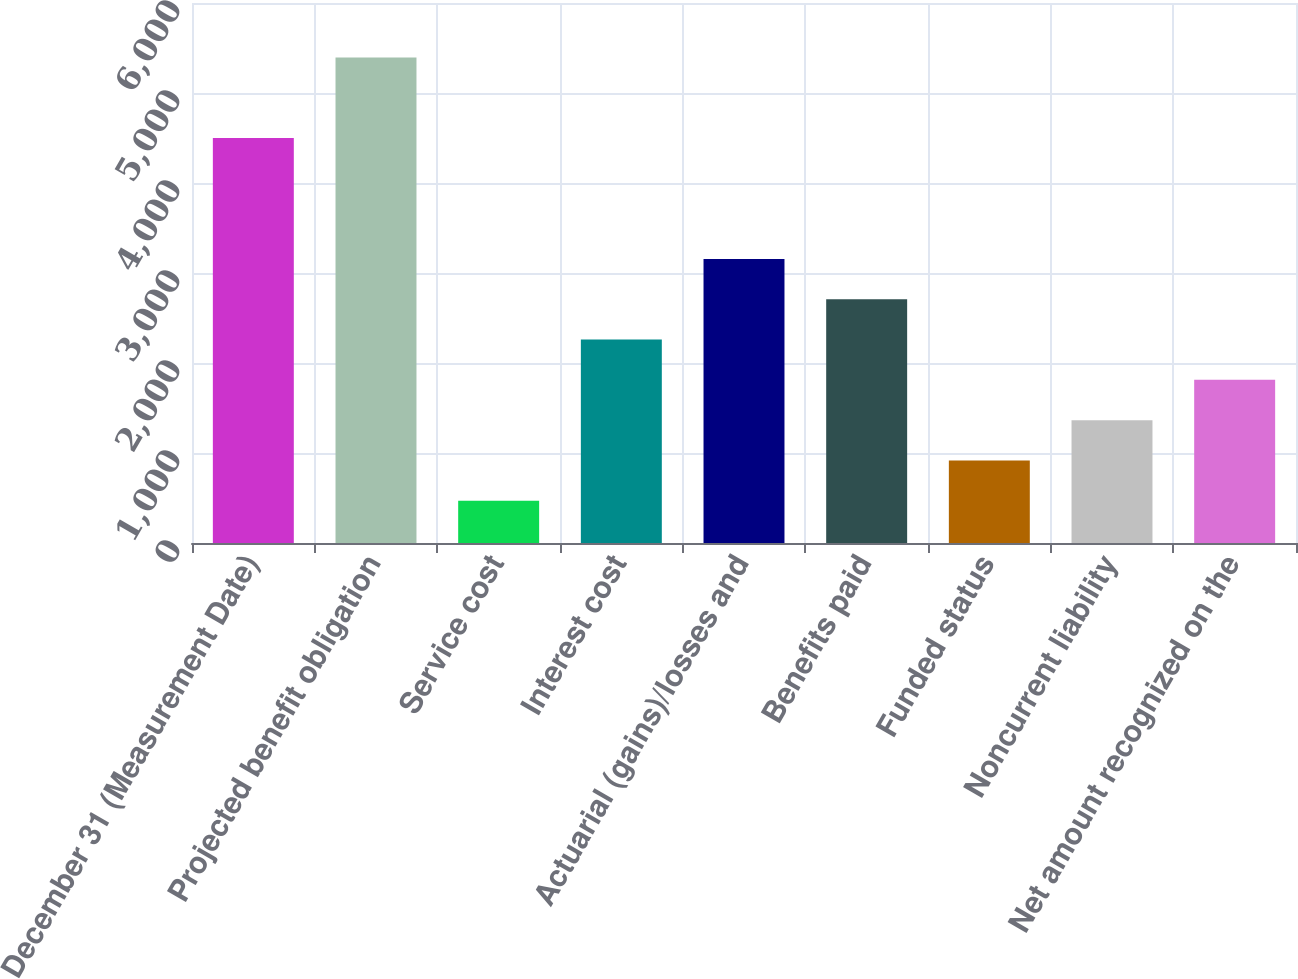Convert chart to OTSL. <chart><loc_0><loc_0><loc_500><loc_500><bar_chart><fcel>December 31 (Measurement Date)<fcel>Projected benefit obligation<fcel>Service cost<fcel>Interest cost<fcel>Actuarial (gains)/losses and<fcel>Benefits paid<fcel>Funded status<fcel>Noncurrent liability<fcel>Net amount recognized on the<nl><fcel>4499<fcel>5394.4<fcel>469.7<fcel>2260.5<fcel>3155.9<fcel>2708.2<fcel>917.4<fcel>1365.1<fcel>1812.8<nl></chart> 